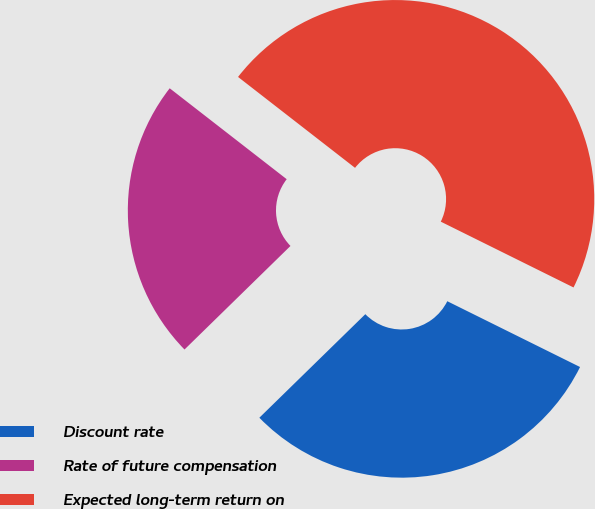Convert chart. <chart><loc_0><loc_0><loc_500><loc_500><pie_chart><fcel>Discount rate<fcel>Rate of future compensation<fcel>Expected long-term return on<nl><fcel>30.36%<fcel>22.83%<fcel>46.81%<nl></chart> 